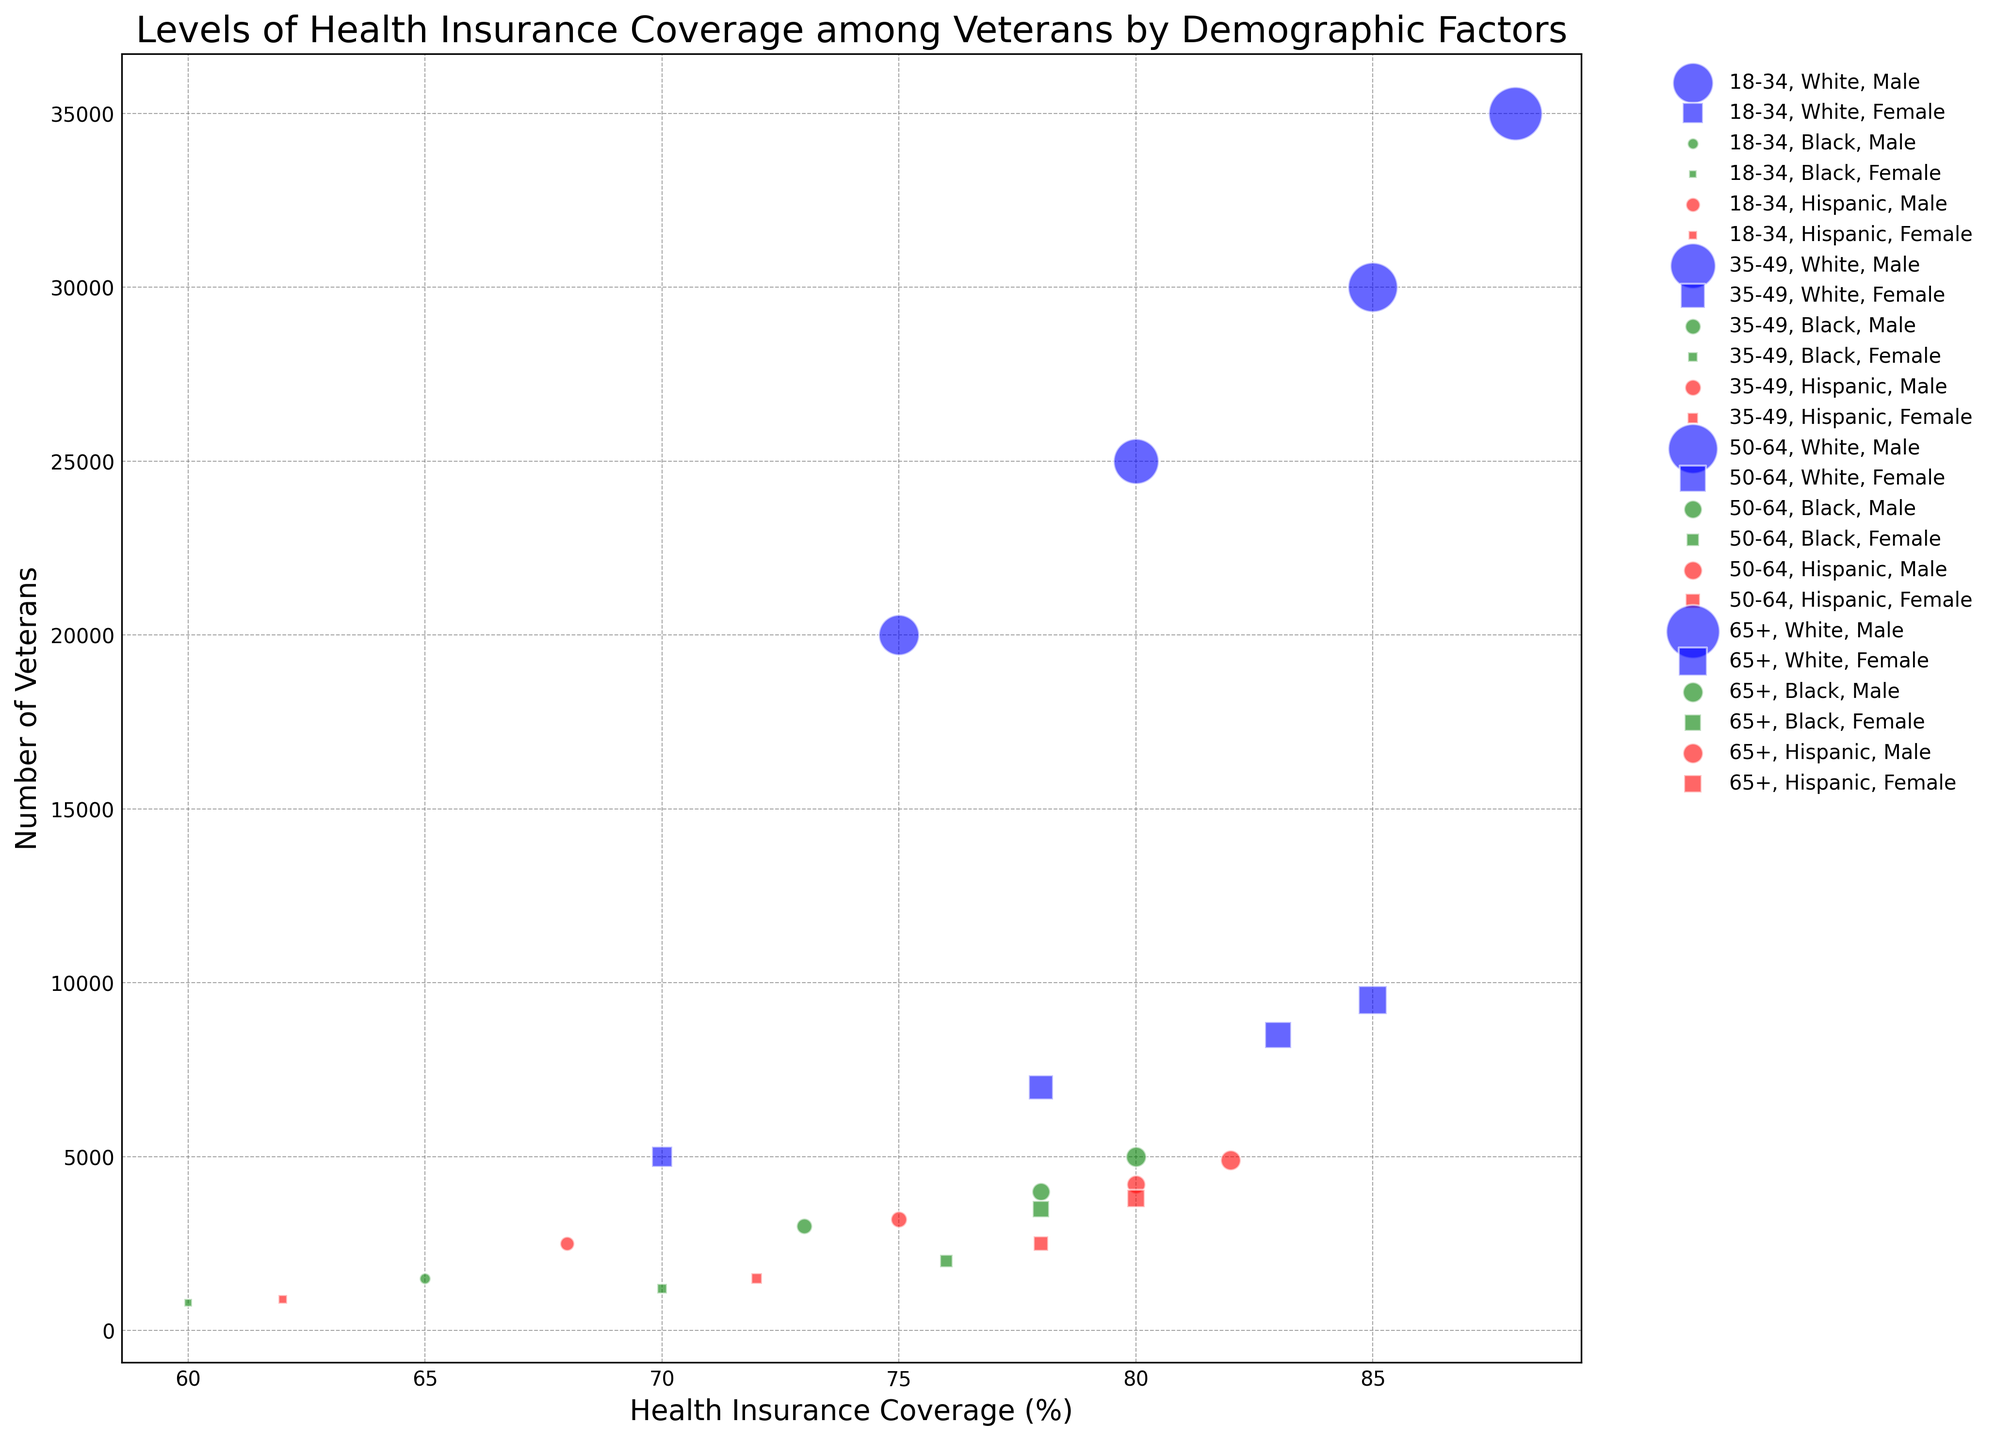What age group has the highest health insurance coverage among Black male veterans? To identify the age group with the highest health insurance coverage among Black male veterans, look at the "Black" category for "Male" under each age group. The health insurance coverage rates are: 65% for 18-34, 73% for 35-49, 78% for 50-64, and 80% for 65+. The 65+ age group has the highest coverage at 80%.
Answer: 65+ Which group has more veterans with health insurance coverage: Hispanic males aged 50-64 or Black males aged 65+? Compare the number of veterans for "Hispanic" males aged 50-64 and "Black" males aged 65+. The numbers are 4,200 for Hispanic males aged 50-64 and 5,000 for Black males aged 65+. Therefore, Black males aged 65+ have more veterans.
Answer: Black males aged 65+ Do white or Hispanic female veterans aged 18-34 have higher health insurance coverage rates? To determine which group has higher health insurance coverage, compare the percentages under "Female" for the 18-34 age group. White females have 70% coverage, and Hispanic females have 62%. Hence, white females have higher coverage.
Answer: White females Which age group among white male veterans has the largest number of veterans? Compare the number of veterans in the different age groups for white males: 20,000 for 18-34, 25,000 for 35-49, 30,000 for 50-64, and 35,000 for 65+. The 65+ age group has the largest number of veterans at 35,000.
Answer: 65+ What is the difference in health insurance coverage between Black females aged 18-34 and Hispanic females aged 65+? Calculate the difference by subtracting the health insurance coverage percentage of Black females aged 18-34 from that of Hispanic females aged 65+. The coverage rates are 60% for Black females aged 18-34 and 80% for Hispanic females aged 65+, giving a difference of 80% - 60% = 20%.
Answer: 20% Among Black veterans aged 35-49, which gender has a higher number of veterans? Compare the number of veterans based on gender for Black veterans aged 35-49. Males have 3,000 veterans, while females have 1,200. Therefore, males have a higher number.
Answer: Male Which age group among Hispanic veterans shows the smallest difference in health insurance coverage between males and females? Calculate the differences for each age group: 18-34 (68% - 62% = 6%), 35-49 (75% - 72% = 3%), 50-64 (80% - 78% = 2%), and 65+ (82% - 80% = 2%). The smallest differences are 2% for both the 50-64 and 65+ age groups.
Answer: 50-64 and 65+ How does the health insurance coverage of White females aged 35-49 compare to White males aged 50-64? Compare the health insurance coverage percentages of these groups. White females aged 35-49 have a coverage rate of 78%, while White males aged 50-64 have a rate of 85%. Males aged 50-64 have higher coverage.
Answer: White males aged 50-64 What is the average health insurance coverage for Black veterans across all age groups? Calculate the average across all age groups by summing the percentages for both genders in each age group and dividing by 8 because there are two genders across four age groups: (65 + 60 + 73 + 70 + 78 + 76 + 80 + 78) / 8 = 72.5%.
Answer: 72.5% Do veterans in the oldest age group (65+) generally have higher health insurance coverage than those in the youngest age group (18-34)? Compare the general trend of health insurance coverage between these two age groups by looking at the data for all races and genders within these groups. Coverage rates for the 65+ group are generally higher (88% for White males, 85% for White females, 80% for Black males, 78% for Black females, 82% for Hispanic males, and 80% for Hispanic females) compared to the 18-34 group (75% for White males, 70% for White females, 65% for Black males, 60% for Black females, 68% for Hispanic males, and 62% for Hispanic females).
Answer: Yes 